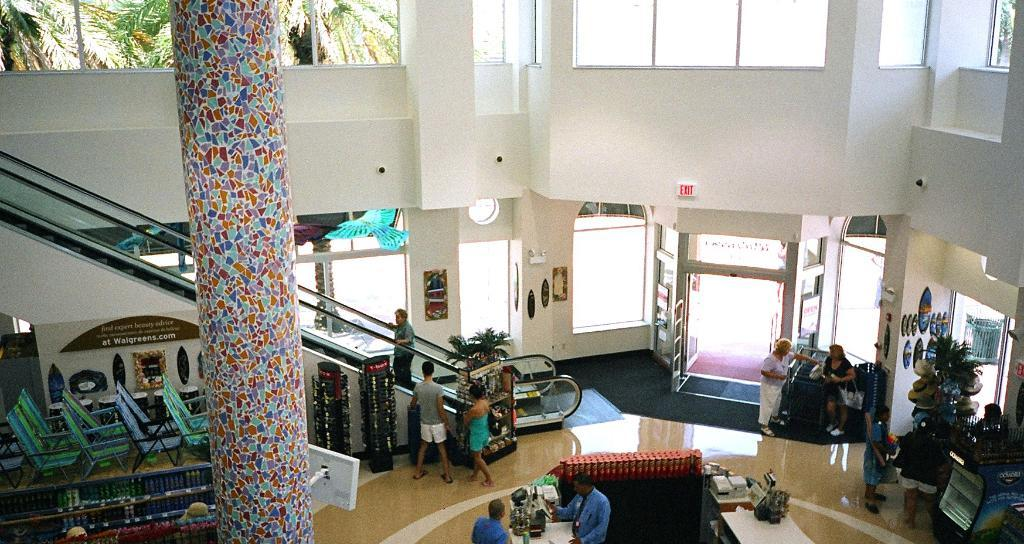What is one of the architectural features in the image? There is a pillar in the image. What is the person in the image doing? There is a person on an escalator in the image. How many people are visible in the image? There are multiple persons in the image. What type of seating is present in the image? There are chairs in the image. What is one of the entrances or exits in the image? There is a door in the image. What allows natural light to enter the space in the image? There are windows in the image. What type of vegetation is present in the image? There are plants and trees in the image. What is one of the boundaries or dividers in the image? There is a wall in the image. Where is the flame coming from in the image? There is no flame present in the image. What type of nerve is visible in the image? There are no nerves present in the image; it is a scene featuring architectural elements and people. 